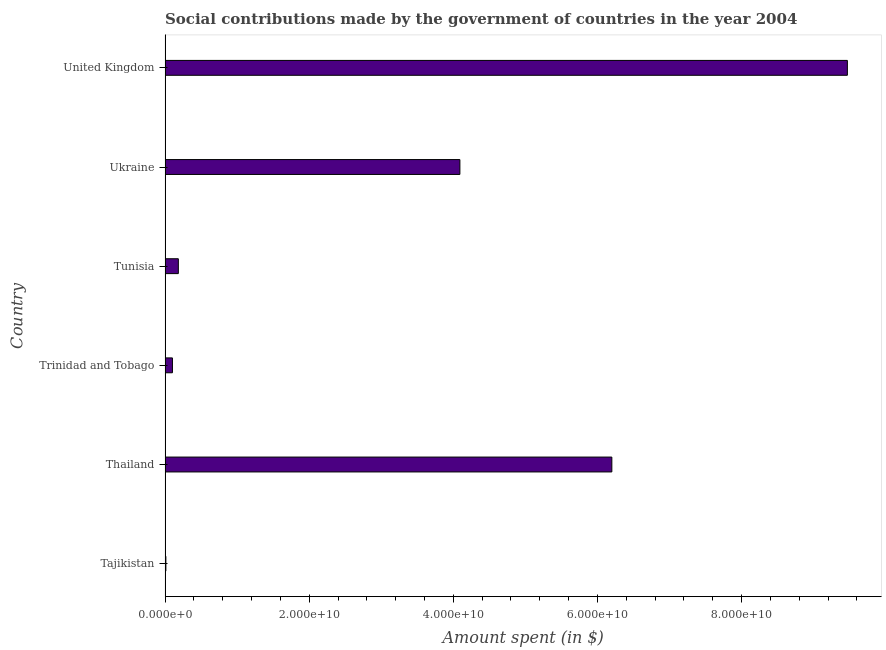What is the title of the graph?
Provide a succinct answer. Social contributions made by the government of countries in the year 2004. What is the label or title of the X-axis?
Give a very brief answer. Amount spent (in $). What is the amount spent in making social contributions in Tajikistan?
Give a very brief answer. 1.09e+08. Across all countries, what is the maximum amount spent in making social contributions?
Make the answer very short. 9.47e+1. Across all countries, what is the minimum amount spent in making social contributions?
Keep it short and to the point. 1.09e+08. In which country was the amount spent in making social contributions maximum?
Offer a very short reply. United Kingdom. In which country was the amount spent in making social contributions minimum?
Provide a short and direct response. Tajikistan. What is the sum of the amount spent in making social contributions?
Your response must be concise. 2.01e+11. What is the difference between the amount spent in making social contributions in Trinidad and Tobago and Tunisia?
Your answer should be compact. -8.18e+08. What is the average amount spent in making social contributions per country?
Your answer should be compact. 3.34e+1. What is the median amount spent in making social contributions?
Your response must be concise. 2.14e+1. What is the ratio of the amount spent in making social contributions in Trinidad and Tobago to that in United Kingdom?
Your response must be concise. 0.01. Is the amount spent in making social contributions in Tajikistan less than that in Trinidad and Tobago?
Ensure brevity in your answer.  Yes. Is the difference between the amount spent in making social contributions in Trinidad and Tobago and Ukraine greater than the difference between any two countries?
Your answer should be compact. No. What is the difference between the highest and the second highest amount spent in making social contributions?
Offer a very short reply. 3.27e+1. What is the difference between the highest and the lowest amount spent in making social contributions?
Provide a short and direct response. 9.46e+1. In how many countries, is the amount spent in making social contributions greater than the average amount spent in making social contributions taken over all countries?
Provide a short and direct response. 3. Are all the bars in the graph horizontal?
Offer a very short reply. Yes. How many countries are there in the graph?
Provide a short and direct response. 6. What is the difference between two consecutive major ticks on the X-axis?
Offer a terse response. 2.00e+1. Are the values on the major ticks of X-axis written in scientific E-notation?
Provide a short and direct response. Yes. What is the Amount spent (in $) of Tajikistan?
Ensure brevity in your answer.  1.09e+08. What is the Amount spent (in $) of Thailand?
Offer a terse response. 6.20e+1. What is the Amount spent (in $) in Trinidad and Tobago?
Make the answer very short. 1.02e+09. What is the Amount spent (in $) in Tunisia?
Ensure brevity in your answer.  1.84e+09. What is the Amount spent (in $) in Ukraine?
Provide a short and direct response. 4.09e+1. What is the Amount spent (in $) of United Kingdom?
Keep it short and to the point. 9.47e+1. What is the difference between the Amount spent (in $) in Tajikistan and Thailand?
Offer a very short reply. -6.19e+1. What is the difference between the Amount spent (in $) in Tajikistan and Trinidad and Tobago?
Ensure brevity in your answer.  -9.11e+08. What is the difference between the Amount spent (in $) in Tajikistan and Tunisia?
Offer a terse response. -1.73e+09. What is the difference between the Amount spent (in $) in Tajikistan and Ukraine?
Make the answer very short. -4.08e+1. What is the difference between the Amount spent (in $) in Tajikistan and United Kingdom?
Offer a very short reply. -9.46e+1. What is the difference between the Amount spent (in $) in Thailand and Trinidad and Tobago?
Provide a succinct answer. 6.10e+1. What is the difference between the Amount spent (in $) in Thailand and Tunisia?
Make the answer very short. 6.02e+1. What is the difference between the Amount spent (in $) in Thailand and Ukraine?
Keep it short and to the point. 2.11e+1. What is the difference between the Amount spent (in $) in Thailand and United Kingdom?
Offer a very short reply. -3.27e+1. What is the difference between the Amount spent (in $) in Trinidad and Tobago and Tunisia?
Make the answer very short. -8.18e+08. What is the difference between the Amount spent (in $) in Trinidad and Tobago and Ukraine?
Offer a terse response. -3.99e+1. What is the difference between the Amount spent (in $) in Trinidad and Tobago and United Kingdom?
Keep it short and to the point. -9.37e+1. What is the difference between the Amount spent (in $) in Tunisia and Ukraine?
Keep it short and to the point. -3.91e+1. What is the difference between the Amount spent (in $) in Tunisia and United Kingdom?
Your answer should be compact. -9.28e+1. What is the difference between the Amount spent (in $) in Ukraine and United Kingdom?
Ensure brevity in your answer.  -5.38e+1. What is the ratio of the Amount spent (in $) in Tajikistan to that in Thailand?
Offer a terse response. 0. What is the ratio of the Amount spent (in $) in Tajikistan to that in Trinidad and Tobago?
Provide a short and direct response. 0.11. What is the ratio of the Amount spent (in $) in Tajikistan to that in Tunisia?
Give a very brief answer. 0.06. What is the ratio of the Amount spent (in $) in Tajikistan to that in Ukraine?
Make the answer very short. 0. What is the ratio of the Amount spent (in $) in Tajikistan to that in United Kingdom?
Keep it short and to the point. 0. What is the ratio of the Amount spent (in $) in Thailand to that in Trinidad and Tobago?
Your answer should be very brief. 60.81. What is the ratio of the Amount spent (in $) in Thailand to that in Tunisia?
Your answer should be compact. 33.74. What is the ratio of the Amount spent (in $) in Thailand to that in Ukraine?
Offer a very short reply. 1.51. What is the ratio of the Amount spent (in $) in Thailand to that in United Kingdom?
Make the answer very short. 0.66. What is the ratio of the Amount spent (in $) in Trinidad and Tobago to that in Tunisia?
Ensure brevity in your answer.  0.56. What is the ratio of the Amount spent (in $) in Trinidad and Tobago to that in Ukraine?
Provide a succinct answer. 0.03. What is the ratio of the Amount spent (in $) in Trinidad and Tobago to that in United Kingdom?
Your answer should be compact. 0.01. What is the ratio of the Amount spent (in $) in Tunisia to that in Ukraine?
Your answer should be very brief. 0.04. What is the ratio of the Amount spent (in $) in Tunisia to that in United Kingdom?
Provide a short and direct response. 0.02. What is the ratio of the Amount spent (in $) in Ukraine to that in United Kingdom?
Ensure brevity in your answer.  0.43. 